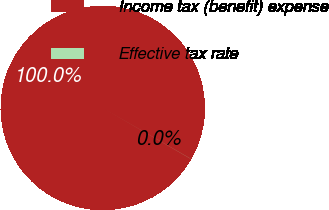Convert chart. <chart><loc_0><loc_0><loc_500><loc_500><pie_chart><fcel>Income tax (benefit) expense<fcel>Effective tax rate<nl><fcel>99.98%<fcel>0.02%<nl></chart> 